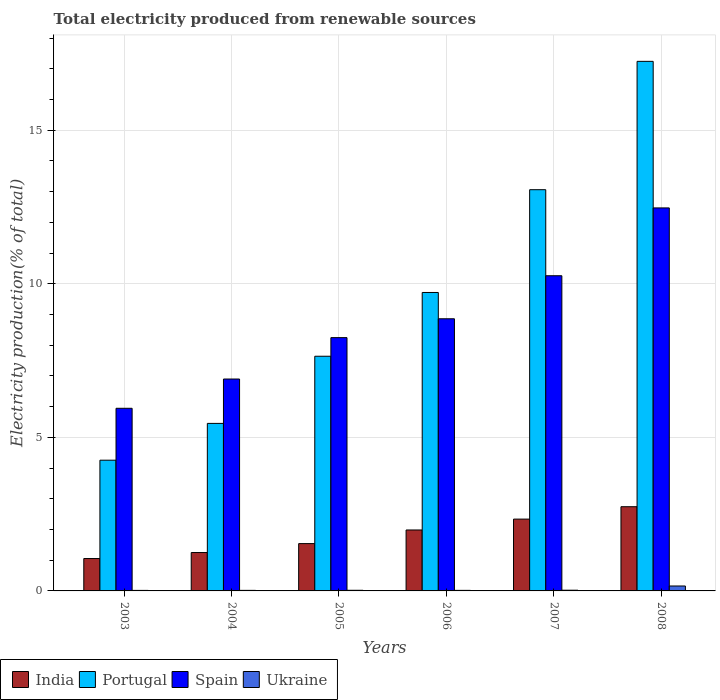How many different coloured bars are there?
Provide a succinct answer. 4. Are the number of bars per tick equal to the number of legend labels?
Provide a succinct answer. Yes. How many bars are there on the 6th tick from the right?
Your answer should be very brief. 4. What is the label of the 2nd group of bars from the left?
Keep it short and to the point. 2004. What is the total electricity produced in India in 2003?
Ensure brevity in your answer.  1.05. Across all years, what is the maximum total electricity produced in Portugal?
Your answer should be compact. 17.24. Across all years, what is the minimum total electricity produced in Ukraine?
Your answer should be very brief. 0.02. What is the total total electricity produced in India in the graph?
Keep it short and to the point. 10.91. What is the difference between the total electricity produced in Spain in 2003 and that in 2008?
Offer a terse response. -6.52. What is the difference between the total electricity produced in Spain in 2005 and the total electricity produced in India in 2004?
Offer a very short reply. 7. What is the average total electricity produced in Portugal per year?
Provide a short and direct response. 9.56. In the year 2003, what is the difference between the total electricity produced in Ukraine and total electricity produced in Spain?
Offer a terse response. -5.93. What is the ratio of the total electricity produced in Portugal in 2007 to that in 2008?
Keep it short and to the point. 0.76. What is the difference between the highest and the second highest total electricity produced in Spain?
Ensure brevity in your answer.  2.21. What is the difference between the highest and the lowest total electricity produced in Ukraine?
Your answer should be very brief. 0.14. Is the sum of the total electricity produced in Portugal in 2005 and 2006 greater than the maximum total electricity produced in Ukraine across all years?
Make the answer very short. Yes. What does the 1st bar from the left in 2008 represents?
Ensure brevity in your answer.  India. Is it the case that in every year, the sum of the total electricity produced in India and total electricity produced in Portugal is greater than the total electricity produced in Spain?
Your response must be concise. No. How many bars are there?
Make the answer very short. 24. How many years are there in the graph?
Your answer should be compact. 6. What is the difference between two consecutive major ticks on the Y-axis?
Give a very brief answer. 5. Are the values on the major ticks of Y-axis written in scientific E-notation?
Provide a succinct answer. No. Does the graph contain grids?
Offer a terse response. Yes. How are the legend labels stacked?
Ensure brevity in your answer.  Horizontal. What is the title of the graph?
Keep it short and to the point. Total electricity produced from renewable sources. Does "Hungary" appear as one of the legend labels in the graph?
Your response must be concise. No. What is the Electricity production(% of total) of India in 2003?
Your answer should be compact. 1.05. What is the Electricity production(% of total) of Portugal in 2003?
Give a very brief answer. 4.26. What is the Electricity production(% of total) in Spain in 2003?
Offer a very short reply. 5.95. What is the Electricity production(% of total) in Ukraine in 2003?
Keep it short and to the point. 0.02. What is the Electricity production(% of total) of India in 2004?
Offer a very short reply. 1.25. What is the Electricity production(% of total) of Portugal in 2004?
Offer a very short reply. 5.45. What is the Electricity production(% of total) in Spain in 2004?
Provide a succinct answer. 6.9. What is the Electricity production(% of total) of Ukraine in 2004?
Make the answer very short. 0.02. What is the Electricity production(% of total) of India in 2005?
Your response must be concise. 1.54. What is the Electricity production(% of total) in Portugal in 2005?
Your response must be concise. 7.64. What is the Electricity production(% of total) in Spain in 2005?
Give a very brief answer. 8.25. What is the Electricity production(% of total) of Ukraine in 2005?
Provide a short and direct response. 0.02. What is the Electricity production(% of total) of India in 2006?
Offer a terse response. 1.98. What is the Electricity production(% of total) of Portugal in 2006?
Your response must be concise. 9.72. What is the Electricity production(% of total) of Spain in 2006?
Provide a short and direct response. 8.86. What is the Electricity production(% of total) in Ukraine in 2006?
Make the answer very short. 0.02. What is the Electricity production(% of total) of India in 2007?
Offer a very short reply. 2.34. What is the Electricity production(% of total) of Portugal in 2007?
Your answer should be very brief. 13.06. What is the Electricity production(% of total) of Spain in 2007?
Your response must be concise. 10.26. What is the Electricity production(% of total) in Ukraine in 2007?
Provide a short and direct response. 0.02. What is the Electricity production(% of total) in India in 2008?
Provide a short and direct response. 2.74. What is the Electricity production(% of total) of Portugal in 2008?
Give a very brief answer. 17.24. What is the Electricity production(% of total) in Spain in 2008?
Your answer should be very brief. 12.47. What is the Electricity production(% of total) of Ukraine in 2008?
Your answer should be very brief. 0.16. Across all years, what is the maximum Electricity production(% of total) in India?
Ensure brevity in your answer.  2.74. Across all years, what is the maximum Electricity production(% of total) in Portugal?
Provide a succinct answer. 17.24. Across all years, what is the maximum Electricity production(% of total) in Spain?
Your answer should be compact. 12.47. Across all years, what is the maximum Electricity production(% of total) in Ukraine?
Provide a succinct answer. 0.16. Across all years, what is the minimum Electricity production(% of total) of India?
Provide a succinct answer. 1.05. Across all years, what is the minimum Electricity production(% of total) in Portugal?
Give a very brief answer. 4.26. Across all years, what is the minimum Electricity production(% of total) in Spain?
Offer a terse response. 5.95. Across all years, what is the minimum Electricity production(% of total) in Ukraine?
Ensure brevity in your answer.  0.02. What is the total Electricity production(% of total) in India in the graph?
Keep it short and to the point. 10.91. What is the total Electricity production(% of total) in Portugal in the graph?
Ensure brevity in your answer.  57.37. What is the total Electricity production(% of total) of Spain in the graph?
Offer a terse response. 52.68. What is the total Electricity production(% of total) of Ukraine in the graph?
Provide a succinct answer. 0.26. What is the difference between the Electricity production(% of total) of India in 2003 and that in 2004?
Give a very brief answer. -0.2. What is the difference between the Electricity production(% of total) of Portugal in 2003 and that in 2004?
Your response must be concise. -1.2. What is the difference between the Electricity production(% of total) of Spain in 2003 and that in 2004?
Offer a very short reply. -0.95. What is the difference between the Electricity production(% of total) of Ukraine in 2003 and that in 2004?
Your answer should be very brief. -0. What is the difference between the Electricity production(% of total) in India in 2003 and that in 2005?
Your answer should be compact. -0.49. What is the difference between the Electricity production(% of total) of Portugal in 2003 and that in 2005?
Provide a succinct answer. -3.38. What is the difference between the Electricity production(% of total) in Spain in 2003 and that in 2005?
Provide a short and direct response. -2.3. What is the difference between the Electricity production(% of total) in Ukraine in 2003 and that in 2005?
Offer a terse response. -0. What is the difference between the Electricity production(% of total) of India in 2003 and that in 2006?
Your answer should be compact. -0.93. What is the difference between the Electricity production(% of total) in Portugal in 2003 and that in 2006?
Offer a terse response. -5.46. What is the difference between the Electricity production(% of total) of Spain in 2003 and that in 2006?
Offer a terse response. -2.91. What is the difference between the Electricity production(% of total) of Ukraine in 2003 and that in 2006?
Keep it short and to the point. -0. What is the difference between the Electricity production(% of total) of India in 2003 and that in 2007?
Keep it short and to the point. -1.28. What is the difference between the Electricity production(% of total) in Portugal in 2003 and that in 2007?
Offer a terse response. -8.81. What is the difference between the Electricity production(% of total) in Spain in 2003 and that in 2007?
Your response must be concise. -4.32. What is the difference between the Electricity production(% of total) of Ukraine in 2003 and that in 2007?
Make the answer very short. -0.01. What is the difference between the Electricity production(% of total) of India in 2003 and that in 2008?
Give a very brief answer. -1.69. What is the difference between the Electricity production(% of total) in Portugal in 2003 and that in 2008?
Provide a short and direct response. -12.99. What is the difference between the Electricity production(% of total) of Spain in 2003 and that in 2008?
Offer a very short reply. -6.52. What is the difference between the Electricity production(% of total) in Ukraine in 2003 and that in 2008?
Offer a very short reply. -0.14. What is the difference between the Electricity production(% of total) of India in 2004 and that in 2005?
Offer a terse response. -0.29. What is the difference between the Electricity production(% of total) of Portugal in 2004 and that in 2005?
Your answer should be very brief. -2.19. What is the difference between the Electricity production(% of total) in Spain in 2004 and that in 2005?
Your answer should be very brief. -1.35. What is the difference between the Electricity production(% of total) of Ukraine in 2004 and that in 2005?
Keep it short and to the point. -0. What is the difference between the Electricity production(% of total) of India in 2004 and that in 2006?
Make the answer very short. -0.73. What is the difference between the Electricity production(% of total) of Portugal in 2004 and that in 2006?
Provide a succinct answer. -4.26. What is the difference between the Electricity production(% of total) in Spain in 2004 and that in 2006?
Ensure brevity in your answer.  -1.96. What is the difference between the Electricity production(% of total) in Ukraine in 2004 and that in 2006?
Your answer should be compact. 0. What is the difference between the Electricity production(% of total) in India in 2004 and that in 2007?
Provide a short and direct response. -1.09. What is the difference between the Electricity production(% of total) in Portugal in 2004 and that in 2007?
Your response must be concise. -7.61. What is the difference between the Electricity production(% of total) in Spain in 2004 and that in 2007?
Your answer should be very brief. -3.36. What is the difference between the Electricity production(% of total) in Ukraine in 2004 and that in 2007?
Ensure brevity in your answer.  -0. What is the difference between the Electricity production(% of total) of India in 2004 and that in 2008?
Provide a short and direct response. -1.49. What is the difference between the Electricity production(% of total) in Portugal in 2004 and that in 2008?
Provide a short and direct response. -11.79. What is the difference between the Electricity production(% of total) in Spain in 2004 and that in 2008?
Offer a very short reply. -5.57. What is the difference between the Electricity production(% of total) in Ukraine in 2004 and that in 2008?
Your answer should be compact. -0.14. What is the difference between the Electricity production(% of total) in India in 2005 and that in 2006?
Make the answer very short. -0.44. What is the difference between the Electricity production(% of total) of Portugal in 2005 and that in 2006?
Offer a terse response. -2.08. What is the difference between the Electricity production(% of total) of Spain in 2005 and that in 2006?
Give a very brief answer. -0.61. What is the difference between the Electricity production(% of total) in Ukraine in 2005 and that in 2006?
Keep it short and to the point. 0. What is the difference between the Electricity production(% of total) of India in 2005 and that in 2007?
Your response must be concise. -0.8. What is the difference between the Electricity production(% of total) in Portugal in 2005 and that in 2007?
Offer a terse response. -5.42. What is the difference between the Electricity production(% of total) in Spain in 2005 and that in 2007?
Ensure brevity in your answer.  -2.01. What is the difference between the Electricity production(% of total) in Ukraine in 2005 and that in 2007?
Offer a terse response. -0. What is the difference between the Electricity production(% of total) of India in 2005 and that in 2008?
Give a very brief answer. -1.2. What is the difference between the Electricity production(% of total) of Portugal in 2005 and that in 2008?
Your response must be concise. -9.6. What is the difference between the Electricity production(% of total) of Spain in 2005 and that in 2008?
Make the answer very short. -4.22. What is the difference between the Electricity production(% of total) in Ukraine in 2005 and that in 2008?
Provide a succinct answer. -0.14. What is the difference between the Electricity production(% of total) in India in 2006 and that in 2007?
Ensure brevity in your answer.  -0.35. What is the difference between the Electricity production(% of total) of Portugal in 2006 and that in 2007?
Your answer should be very brief. -3.35. What is the difference between the Electricity production(% of total) of Spain in 2006 and that in 2007?
Offer a very short reply. -1.4. What is the difference between the Electricity production(% of total) in Ukraine in 2006 and that in 2007?
Offer a terse response. -0. What is the difference between the Electricity production(% of total) of India in 2006 and that in 2008?
Provide a succinct answer. -0.76. What is the difference between the Electricity production(% of total) of Portugal in 2006 and that in 2008?
Keep it short and to the point. -7.53. What is the difference between the Electricity production(% of total) of Spain in 2006 and that in 2008?
Keep it short and to the point. -3.61. What is the difference between the Electricity production(% of total) in Ukraine in 2006 and that in 2008?
Give a very brief answer. -0.14. What is the difference between the Electricity production(% of total) in India in 2007 and that in 2008?
Ensure brevity in your answer.  -0.4. What is the difference between the Electricity production(% of total) of Portugal in 2007 and that in 2008?
Provide a succinct answer. -4.18. What is the difference between the Electricity production(% of total) in Spain in 2007 and that in 2008?
Provide a short and direct response. -2.21. What is the difference between the Electricity production(% of total) in Ukraine in 2007 and that in 2008?
Provide a short and direct response. -0.14. What is the difference between the Electricity production(% of total) of India in 2003 and the Electricity production(% of total) of Portugal in 2004?
Give a very brief answer. -4.4. What is the difference between the Electricity production(% of total) in India in 2003 and the Electricity production(% of total) in Spain in 2004?
Your answer should be very brief. -5.84. What is the difference between the Electricity production(% of total) of India in 2003 and the Electricity production(% of total) of Ukraine in 2004?
Make the answer very short. 1.04. What is the difference between the Electricity production(% of total) in Portugal in 2003 and the Electricity production(% of total) in Spain in 2004?
Make the answer very short. -2.64. What is the difference between the Electricity production(% of total) of Portugal in 2003 and the Electricity production(% of total) of Ukraine in 2004?
Your answer should be compact. 4.24. What is the difference between the Electricity production(% of total) of Spain in 2003 and the Electricity production(% of total) of Ukraine in 2004?
Give a very brief answer. 5.93. What is the difference between the Electricity production(% of total) in India in 2003 and the Electricity production(% of total) in Portugal in 2005?
Your answer should be compact. -6.59. What is the difference between the Electricity production(% of total) in India in 2003 and the Electricity production(% of total) in Spain in 2005?
Your response must be concise. -7.19. What is the difference between the Electricity production(% of total) in India in 2003 and the Electricity production(% of total) in Ukraine in 2005?
Provide a short and direct response. 1.03. What is the difference between the Electricity production(% of total) of Portugal in 2003 and the Electricity production(% of total) of Spain in 2005?
Your answer should be compact. -3.99. What is the difference between the Electricity production(% of total) of Portugal in 2003 and the Electricity production(% of total) of Ukraine in 2005?
Offer a terse response. 4.24. What is the difference between the Electricity production(% of total) of Spain in 2003 and the Electricity production(% of total) of Ukraine in 2005?
Your answer should be compact. 5.93. What is the difference between the Electricity production(% of total) of India in 2003 and the Electricity production(% of total) of Portugal in 2006?
Provide a succinct answer. -8.66. What is the difference between the Electricity production(% of total) of India in 2003 and the Electricity production(% of total) of Spain in 2006?
Give a very brief answer. -7.81. What is the difference between the Electricity production(% of total) in India in 2003 and the Electricity production(% of total) in Ukraine in 2006?
Give a very brief answer. 1.04. What is the difference between the Electricity production(% of total) in Portugal in 2003 and the Electricity production(% of total) in Spain in 2006?
Give a very brief answer. -4.6. What is the difference between the Electricity production(% of total) in Portugal in 2003 and the Electricity production(% of total) in Ukraine in 2006?
Keep it short and to the point. 4.24. What is the difference between the Electricity production(% of total) in Spain in 2003 and the Electricity production(% of total) in Ukraine in 2006?
Provide a succinct answer. 5.93. What is the difference between the Electricity production(% of total) in India in 2003 and the Electricity production(% of total) in Portugal in 2007?
Your answer should be very brief. -12.01. What is the difference between the Electricity production(% of total) in India in 2003 and the Electricity production(% of total) in Spain in 2007?
Offer a very short reply. -9.21. What is the difference between the Electricity production(% of total) in India in 2003 and the Electricity production(% of total) in Ukraine in 2007?
Your response must be concise. 1.03. What is the difference between the Electricity production(% of total) of Portugal in 2003 and the Electricity production(% of total) of Spain in 2007?
Give a very brief answer. -6.01. What is the difference between the Electricity production(% of total) of Portugal in 2003 and the Electricity production(% of total) of Ukraine in 2007?
Your answer should be very brief. 4.23. What is the difference between the Electricity production(% of total) in Spain in 2003 and the Electricity production(% of total) in Ukraine in 2007?
Keep it short and to the point. 5.92. What is the difference between the Electricity production(% of total) of India in 2003 and the Electricity production(% of total) of Portugal in 2008?
Your response must be concise. -16.19. What is the difference between the Electricity production(% of total) in India in 2003 and the Electricity production(% of total) in Spain in 2008?
Provide a short and direct response. -11.42. What is the difference between the Electricity production(% of total) in India in 2003 and the Electricity production(% of total) in Ukraine in 2008?
Make the answer very short. 0.89. What is the difference between the Electricity production(% of total) in Portugal in 2003 and the Electricity production(% of total) in Spain in 2008?
Your response must be concise. -8.21. What is the difference between the Electricity production(% of total) of Portugal in 2003 and the Electricity production(% of total) of Ukraine in 2008?
Make the answer very short. 4.1. What is the difference between the Electricity production(% of total) in Spain in 2003 and the Electricity production(% of total) in Ukraine in 2008?
Provide a succinct answer. 5.79. What is the difference between the Electricity production(% of total) of India in 2004 and the Electricity production(% of total) of Portugal in 2005?
Offer a terse response. -6.39. What is the difference between the Electricity production(% of total) in India in 2004 and the Electricity production(% of total) in Spain in 2005?
Your response must be concise. -7. What is the difference between the Electricity production(% of total) of India in 2004 and the Electricity production(% of total) of Ukraine in 2005?
Make the answer very short. 1.23. What is the difference between the Electricity production(% of total) in Portugal in 2004 and the Electricity production(% of total) in Spain in 2005?
Give a very brief answer. -2.79. What is the difference between the Electricity production(% of total) of Portugal in 2004 and the Electricity production(% of total) of Ukraine in 2005?
Your response must be concise. 5.43. What is the difference between the Electricity production(% of total) of Spain in 2004 and the Electricity production(% of total) of Ukraine in 2005?
Give a very brief answer. 6.88. What is the difference between the Electricity production(% of total) of India in 2004 and the Electricity production(% of total) of Portugal in 2006?
Keep it short and to the point. -8.47. What is the difference between the Electricity production(% of total) in India in 2004 and the Electricity production(% of total) in Spain in 2006?
Provide a succinct answer. -7.61. What is the difference between the Electricity production(% of total) in India in 2004 and the Electricity production(% of total) in Ukraine in 2006?
Your response must be concise. 1.23. What is the difference between the Electricity production(% of total) in Portugal in 2004 and the Electricity production(% of total) in Spain in 2006?
Ensure brevity in your answer.  -3.41. What is the difference between the Electricity production(% of total) in Portugal in 2004 and the Electricity production(% of total) in Ukraine in 2006?
Ensure brevity in your answer.  5.44. What is the difference between the Electricity production(% of total) of Spain in 2004 and the Electricity production(% of total) of Ukraine in 2006?
Keep it short and to the point. 6.88. What is the difference between the Electricity production(% of total) of India in 2004 and the Electricity production(% of total) of Portugal in 2007?
Your answer should be very brief. -11.81. What is the difference between the Electricity production(% of total) of India in 2004 and the Electricity production(% of total) of Spain in 2007?
Your answer should be very brief. -9.01. What is the difference between the Electricity production(% of total) in India in 2004 and the Electricity production(% of total) in Ukraine in 2007?
Provide a succinct answer. 1.23. What is the difference between the Electricity production(% of total) in Portugal in 2004 and the Electricity production(% of total) in Spain in 2007?
Provide a short and direct response. -4.81. What is the difference between the Electricity production(% of total) in Portugal in 2004 and the Electricity production(% of total) in Ukraine in 2007?
Provide a succinct answer. 5.43. What is the difference between the Electricity production(% of total) in Spain in 2004 and the Electricity production(% of total) in Ukraine in 2007?
Give a very brief answer. 6.88. What is the difference between the Electricity production(% of total) in India in 2004 and the Electricity production(% of total) in Portugal in 2008?
Provide a short and direct response. -15.99. What is the difference between the Electricity production(% of total) in India in 2004 and the Electricity production(% of total) in Spain in 2008?
Your answer should be very brief. -11.22. What is the difference between the Electricity production(% of total) of India in 2004 and the Electricity production(% of total) of Ukraine in 2008?
Your answer should be very brief. 1.09. What is the difference between the Electricity production(% of total) of Portugal in 2004 and the Electricity production(% of total) of Spain in 2008?
Give a very brief answer. -7.02. What is the difference between the Electricity production(% of total) in Portugal in 2004 and the Electricity production(% of total) in Ukraine in 2008?
Your answer should be compact. 5.29. What is the difference between the Electricity production(% of total) of Spain in 2004 and the Electricity production(% of total) of Ukraine in 2008?
Your answer should be very brief. 6.74. What is the difference between the Electricity production(% of total) in India in 2005 and the Electricity production(% of total) in Portugal in 2006?
Your answer should be compact. -8.18. What is the difference between the Electricity production(% of total) in India in 2005 and the Electricity production(% of total) in Spain in 2006?
Ensure brevity in your answer.  -7.32. What is the difference between the Electricity production(% of total) in India in 2005 and the Electricity production(% of total) in Ukraine in 2006?
Keep it short and to the point. 1.52. What is the difference between the Electricity production(% of total) in Portugal in 2005 and the Electricity production(% of total) in Spain in 2006?
Your response must be concise. -1.22. What is the difference between the Electricity production(% of total) in Portugal in 2005 and the Electricity production(% of total) in Ukraine in 2006?
Your answer should be compact. 7.62. What is the difference between the Electricity production(% of total) in Spain in 2005 and the Electricity production(% of total) in Ukraine in 2006?
Your answer should be very brief. 8.23. What is the difference between the Electricity production(% of total) in India in 2005 and the Electricity production(% of total) in Portugal in 2007?
Your answer should be very brief. -11.52. What is the difference between the Electricity production(% of total) in India in 2005 and the Electricity production(% of total) in Spain in 2007?
Provide a succinct answer. -8.72. What is the difference between the Electricity production(% of total) in India in 2005 and the Electricity production(% of total) in Ukraine in 2007?
Keep it short and to the point. 1.52. What is the difference between the Electricity production(% of total) of Portugal in 2005 and the Electricity production(% of total) of Spain in 2007?
Provide a short and direct response. -2.62. What is the difference between the Electricity production(% of total) of Portugal in 2005 and the Electricity production(% of total) of Ukraine in 2007?
Ensure brevity in your answer.  7.62. What is the difference between the Electricity production(% of total) of Spain in 2005 and the Electricity production(% of total) of Ukraine in 2007?
Your answer should be very brief. 8.22. What is the difference between the Electricity production(% of total) in India in 2005 and the Electricity production(% of total) in Portugal in 2008?
Offer a terse response. -15.7. What is the difference between the Electricity production(% of total) of India in 2005 and the Electricity production(% of total) of Spain in 2008?
Your answer should be very brief. -10.93. What is the difference between the Electricity production(% of total) of India in 2005 and the Electricity production(% of total) of Ukraine in 2008?
Your response must be concise. 1.38. What is the difference between the Electricity production(% of total) of Portugal in 2005 and the Electricity production(% of total) of Spain in 2008?
Give a very brief answer. -4.83. What is the difference between the Electricity production(% of total) of Portugal in 2005 and the Electricity production(% of total) of Ukraine in 2008?
Your answer should be compact. 7.48. What is the difference between the Electricity production(% of total) in Spain in 2005 and the Electricity production(% of total) in Ukraine in 2008?
Your answer should be compact. 8.09. What is the difference between the Electricity production(% of total) of India in 2006 and the Electricity production(% of total) of Portugal in 2007?
Offer a very short reply. -11.08. What is the difference between the Electricity production(% of total) of India in 2006 and the Electricity production(% of total) of Spain in 2007?
Offer a terse response. -8.28. What is the difference between the Electricity production(% of total) in India in 2006 and the Electricity production(% of total) in Ukraine in 2007?
Offer a terse response. 1.96. What is the difference between the Electricity production(% of total) of Portugal in 2006 and the Electricity production(% of total) of Spain in 2007?
Provide a short and direct response. -0.55. What is the difference between the Electricity production(% of total) of Portugal in 2006 and the Electricity production(% of total) of Ukraine in 2007?
Offer a terse response. 9.69. What is the difference between the Electricity production(% of total) in Spain in 2006 and the Electricity production(% of total) in Ukraine in 2007?
Give a very brief answer. 8.84. What is the difference between the Electricity production(% of total) of India in 2006 and the Electricity production(% of total) of Portugal in 2008?
Make the answer very short. -15.26. What is the difference between the Electricity production(% of total) in India in 2006 and the Electricity production(% of total) in Spain in 2008?
Ensure brevity in your answer.  -10.49. What is the difference between the Electricity production(% of total) of India in 2006 and the Electricity production(% of total) of Ukraine in 2008?
Your response must be concise. 1.82. What is the difference between the Electricity production(% of total) in Portugal in 2006 and the Electricity production(% of total) in Spain in 2008?
Make the answer very short. -2.75. What is the difference between the Electricity production(% of total) in Portugal in 2006 and the Electricity production(% of total) in Ukraine in 2008?
Offer a terse response. 9.56. What is the difference between the Electricity production(% of total) of India in 2007 and the Electricity production(% of total) of Portugal in 2008?
Provide a succinct answer. -14.9. What is the difference between the Electricity production(% of total) of India in 2007 and the Electricity production(% of total) of Spain in 2008?
Give a very brief answer. -10.13. What is the difference between the Electricity production(% of total) in India in 2007 and the Electricity production(% of total) in Ukraine in 2008?
Give a very brief answer. 2.18. What is the difference between the Electricity production(% of total) in Portugal in 2007 and the Electricity production(% of total) in Spain in 2008?
Your response must be concise. 0.59. What is the difference between the Electricity production(% of total) in Portugal in 2007 and the Electricity production(% of total) in Ukraine in 2008?
Keep it short and to the point. 12.9. What is the difference between the Electricity production(% of total) of Spain in 2007 and the Electricity production(% of total) of Ukraine in 2008?
Give a very brief answer. 10.1. What is the average Electricity production(% of total) of India per year?
Keep it short and to the point. 1.82. What is the average Electricity production(% of total) of Portugal per year?
Provide a succinct answer. 9.56. What is the average Electricity production(% of total) in Spain per year?
Keep it short and to the point. 8.78. What is the average Electricity production(% of total) in Ukraine per year?
Keep it short and to the point. 0.04. In the year 2003, what is the difference between the Electricity production(% of total) of India and Electricity production(% of total) of Portugal?
Ensure brevity in your answer.  -3.2. In the year 2003, what is the difference between the Electricity production(% of total) in India and Electricity production(% of total) in Spain?
Ensure brevity in your answer.  -4.89. In the year 2003, what is the difference between the Electricity production(% of total) of India and Electricity production(% of total) of Ukraine?
Provide a short and direct response. 1.04. In the year 2003, what is the difference between the Electricity production(% of total) of Portugal and Electricity production(% of total) of Spain?
Give a very brief answer. -1.69. In the year 2003, what is the difference between the Electricity production(% of total) of Portugal and Electricity production(% of total) of Ukraine?
Give a very brief answer. 4.24. In the year 2003, what is the difference between the Electricity production(% of total) of Spain and Electricity production(% of total) of Ukraine?
Make the answer very short. 5.93. In the year 2004, what is the difference between the Electricity production(% of total) in India and Electricity production(% of total) in Portugal?
Your response must be concise. -4.2. In the year 2004, what is the difference between the Electricity production(% of total) in India and Electricity production(% of total) in Spain?
Give a very brief answer. -5.65. In the year 2004, what is the difference between the Electricity production(% of total) of India and Electricity production(% of total) of Ukraine?
Offer a terse response. 1.23. In the year 2004, what is the difference between the Electricity production(% of total) in Portugal and Electricity production(% of total) in Spain?
Your answer should be compact. -1.44. In the year 2004, what is the difference between the Electricity production(% of total) of Portugal and Electricity production(% of total) of Ukraine?
Your response must be concise. 5.44. In the year 2004, what is the difference between the Electricity production(% of total) in Spain and Electricity production(% of total) in Ukraine?
Provide a succinct answer. 6.88. In the year 2005, what is the difference between the Electricity production(% of total) of India and Electricity production(% of total) of Spain?
Make the answer very short. -6.71. In the year 2005, what is the difference between the Electricity production(% of total) of India and Electricity production(% of total) of Ukraine?
Give a very brief answer. 1.52. In the year 2005, what is the difference between the Electricity production(% of total) in Portugal and Electricity production(% of total) in Spain?
Your answer should be very brief. -0.61. In the year 2005, what is the difference between the Electricity production(% of total) of Portugal and Electricity production(% of total) of Ukraine?
Make the answer very short. 7.62. In the year 2005, what is the difference between the Electricity production(% of total) in Spain and Electricity production(% of total) in Ukraine?
Give a very brief answer. 8.23. In the year 2006, what is the difference between the Electricity production(% of total) of India and Electricity production(% of total) of Portugal?
Provide a short and direct response. -7.73. In the year 2006, what is the difference between the Electricity production(% of total) in India and Electricity production(% of total) in Spain?
Your answer should be compact. -6.88. In the year 2006, what is the difference between the Electricity production(% of total) in India and Electricity production(% of total) in Ukraine?
Ensure brevity in your answer.  1.97. In the year 2006, what is the difference between the Electricity production(% of total) of Portugal and Electricity production(% of total) of Spain?
Give a very brief answer. 0.86. In the year 2006, what is the difference between the Electricity production(% of total) in Portugal and Electricity production(% of total) in Ukraine?
Your answer should be compact. 9.7. In the year 2006, what is the difference between the Electricity production(% of total) in Spain and Electricity production(% of total) in Ukraine?
Make the answer very short. 8.84. In the year 2007, what is the difference between the Electricity production(% of total) in India and Electricity production(% of total) in Portugal?
Ensure brevity in your answer.  -10.72. In the year 2007, what is the difference between the Electricity production(% of total) in India and Electricity production(% of total) in Spain?
Provide a succinct answer. -7.92. In the year 2007, what is the difference between the Electricity production(% of total) in India and Electricity production(% of total) in Ukraine?
Make the answer very short. 2.32. In the year 2007, what is the difference between the Electricity production(% of total) of Portugal and Electricity production(% of total) of Spain?
Offer a very short reply. 2.8. In the year 2007, what is the difference between the Electricity production(% of total) of Portugal and Electricity production(% of total) of Ukraine?
Your response must be concise. 13.04. In the year 2007, what is the difference between the Electricity production(% of total) of Spain and Electricity production(% of total) of Ukraine?
Ensure brevity in your answer.  10.24. In the year 2008, what is the difference between the Electricity production(% of total) of India and Electricity production(% of total) of Portugal?
Offer a very short reply. -14.5. In the year 2008, what is the difference between the Electricity production(% of total) of India and Electricity production(% of total) of Spain?
Your answer should be very brief. -9.73. In the year 2008, what is the difference between the Electricity production(% of total) of India and Electricity production(% of total) of Ukraine?
Provide a succinct answer. 2.58. In the year 2008, what is the difference between the Electricity production(% of total) in Portugal and Electricity production(% of total) in Spain?
Make the answer very short. 4.77. In the year 2008, what is the difference between the Electricity production(% of total) in Portugal and Electricity production(% of total) in Ukraine?
Your response must be concise. 17.08. In the year 2008, what is the difference between the Electricity production(% of total) of Spain and Electricity production(% of total) of Ukraine?
Offer a very short reply. 12.31. What is the ratio of the Electricity production(% of total) in India in 2003 to that in 2004?
Give a very brief answer. 0.84. What is the ratio of the Electricity production(% of total) of Portugal in 2003 to that in 2004?
Your response must be concise. 0.78. What is the ratio of the Electricity production(% of total) of Spain in 2003 to that in 2004?
Ensure brevity in your answer.  0.86. What is the ratio of the Electricity production(% of total) of Ukraine in 2003 to that in 2004?
Give a very brief answer. 0.95. What is the ratio of the Electricity production(% of total) of India in 2003 to that in 2005?
Make the answer very short. 0.68. What is the ratio of the Electricity production(% of total) of Portugal in 2003 to that in 2005?
Give a very brief answer. 0.56. What is the ratio of the Electricity production(% of total) of Spain in 2003 to that in 2005?
Offer a terse response. 0.72. What is the ratio of the Electricity production(% of total) in Ukraine in 2003 to that in 2005?
Provide a succinct answer. 0.84. What is the ratio of the Electricity production(% of total) in India in 2003 to that in 2006?
Give a very brief answer. 0.53. What is the ratio of the Electricity production(% of total) of Portugal in 2003 to that in 2006?
Your response must be concise. 0.44. What is the ratio of the Electricity production(% of total) in Spain in 2003 to that in 2006?
Offer a terse response. 0.67. What is the ratio of the Electricity production(% of total) of Ukraine in 2003 to that in 2006?
Offer a very short reply. 0.95. What is the ratio of the Electricity production(% of total) of India in 2003 to that in 2007?
Keep it short and to the point. 0.45. What is the ratio of the Electricity production(% of total) in Portugal in 2003 to that in 2007?
Your answer should be very brief. 0.33. What is the ratio of the Electricity production(% of total) of Spain in 2003 to that in 2007?
Your response must be concise. 0.58. What is the ratio of the Electricity production(% of total) of Ukraine in 2003 to that in 2007?
Give a very brief answer. 0.75. What is the ratio of the Electricity production(% of total) of India in 2003 to that in 2008?
Offer a very short reply. 0.38. What is the ratio of the Electricity production(% of total) of Portugal in 2003 to that in 2008?
Your response must be concise. 0.25. What is the ratio of the Electricity production(% of total) in Spain in 2003 to that in 2008?
Keep it short and to the point. 0.48. What is the ratio of the Electricity production(% of total) in Ukraine in 2003 to that in 2008?
Offer a very short reply. 0.11. What is the ratio of the Electricity production(% of total) in India in 2004 to that in 2005?
Offer a very short reply. 0.81. What is the ratio of the Electricity production(% of total) in Portugal in 2004 to that in 2005?
Offer a very short reply. 0.71. What is the ratio of the Electricity production(% of total) of Spain in 2004 to that in 2005?
Keep it short and to the point. 0.84. What is the ratio of the Electricity production(% of total) in Ukraine in 2004 to that in 2005?
Offer a terse response. 0.89. What is the ratio of the Electricity production(% of total) in India in 2004 to that in 2006?
Ensure brevity in your answer.  0.63. What is the ratio of the Electricity production(% of total) of Portugal in 2004 to that in 2006?
Provide a short and direct response. 0.56. What is the ratio of the Electricity production(% of total) of Spain in 2004 to that in 2006?
Your answer should be very brief. 0.78. What is the ratio of the Electricity production(% of total) of Ukraine in 2004 to that in 2006?
Your answer should be very brief. 1. What is the ratio of the Electricity production(% of total) in India in 2004 to that in 2007?
Your response must be concise. 0.53. What is the ratio of the Electricity production(% of total) in Portugal in 2004 to that in 2007?
Ensure brevity in your answer.  0.42. What is the ratio of the Electricity production(% of total) in Spain in 2004 to that in 2007?
Offer a very short reply. 0.67. What is the ratio of the Electricity production(% of total) in Ukraine in 2004 to that in 2007?
Offer a very short reply. 0.79. What is the ratio of the Electricity production(% of total) in India in 2004 to that in 2008?
Offer a terse response. 0.46. What is the ratio of the Electricity production(% of total) in Portugal in 2004 to that in 2008?
Ensure brevity in your answer.  0.32. What is the ratio of the Electricity production(% of total) in Spain in 2004 to that in 2008?
Offer a terse response. 0.55. What is the ratio of the Electricity production(% of total) in Ukraine in 2004 to that in 2008?
Offer a terse response. 0.11. What is the ratio of the Electricity production(% of total) of India in 2005 to that in 2006?
Provide a succinct answer. 0.78. What is the ratio of the Electricity production(% of total) in Portugal in 2005 to that in 2006?
Give a very brief answer. 0.79. What is the ratio of the Electricity production(% of total) in Spain in 2005 to that in 2006?
Offer a terse response. 0.93. What is the ratio of the Electricity production(% of total) in Ukraine in 2005 to that in 2006?
Ensure brevity in your answer.  1.13. What is the ratio of the Electricity production(% of total) in India in 2005 to that in 2007?
Your response must be concise. 0.66. What is the ratio of the Electricity production(% of total) in Portugal in 2005 to that in 2007?
Provide a succinct answer. 0.58. What is the ratio of the Electricity production(% of total) in Spain in 2005 to that in 2007?
Offer a very short reply. 0.8. What is the ratio of the Electricity production(% of total) in Ukraine in 2005 to that in 2007?
Ensure brevity in your answer.  0.89. What is the ratio of the Electricity production(% of total) in India in 2005 to that in 2008?
Give a very brief answer. 0.56. What is the ratio of the Electricity production(% of total) in Portugal in 2005 to that in 2008?
Keep it short and to the point. 0.44. What is the ratio of the Electricity production(% of total) of Spain in 2005 to that in 2008?
Offer a terse response. 0.66. What is the ratio of the Electricity production(% of total) of Ukraine in 2005 to that in 2008?
Your answer should be compact. 0.13. What is the ratio of the Electricity production(% of total) of India in 2006 to that in 2007?
Keep it short and to the point. 0.85. What is the ratio of the Electricity production(% of total) of Portugal in 2006 to that in 2007?
Keep it short and to the point. 0.74. What is the ratio of the Electricity production(% of total) in Spain in 2006 to that in 2007?
Ensure brevity in your answer.  0.86. What is the ratio of the Electricity production(% of total) in Ukraine in 2006 to that in 2007?
Keep it short and to the point. 0.79. What is the ratio of the Electricity production(% of total) of India in 2006 to that in 2008?
Your response must be concise. 0.72. What is the ratio of the Electricity production(% of total) of Portugal in 2006 to that in 2008?
Provide a succinct answer. 0.56. What is the ratio of the Electricity production(% of total) in Spain in 2006 to that in 2008?
Keep it short and to the point. 0.71. What is the ratio of the Electricity production(% of total) of Ukraine in 2006 to that in 2008?
Your answer should be very brief. 0.11. What is the ratio of the Electricity production(% of total) of India in 2007 to that in 2008?
Make the answer very short. 0.85. What is the ratio of the Electricity production(% of total) in Portugal in 2007 to that in 2008?
Provide a short and direct response. 0.76. What is the ratio of the Electricity production(% of total) in Spain in 2007 to that in 2008?
Keep it short and to the point. 0.82. What is the ratio of the Electricity production(% of total) in Ukraine in 2007 to that in 2008?
Offer a terse response. 0.14. What is the difference between the highest and the second highest Electricity production(% of total) in India?
Your answer should be very brief. 0.4. What is the difference between the highest and the second highest Electricity production(% of total) of Portugal?
Offer a very short reply. 4.18. What is the difference between the highest and the second highest Electricity production(% of total) in Spain?
Ensure brevity in your answer.  2.21. What is the difference between the highest and the second highest Electricity production(% of total) of Ukraine?
Give a very brief answer. 0.14. What is the difference between the highest and the lowest Electricity production(% of total) of India?
Keep it short and to the point. 1.69. What is the difference between the highest and the lowest Electricity production(% of total) in Portugal?
Your response must be concise. 12.99. What is the difference between the highest and the lowest Electricity production(% of total) in Spain?
Your response must be concise. 6.52. What is the difference between the highest and the lowest Electricity production(% of total) of Ukraine?
Provide a short and direct response. 0.14. 